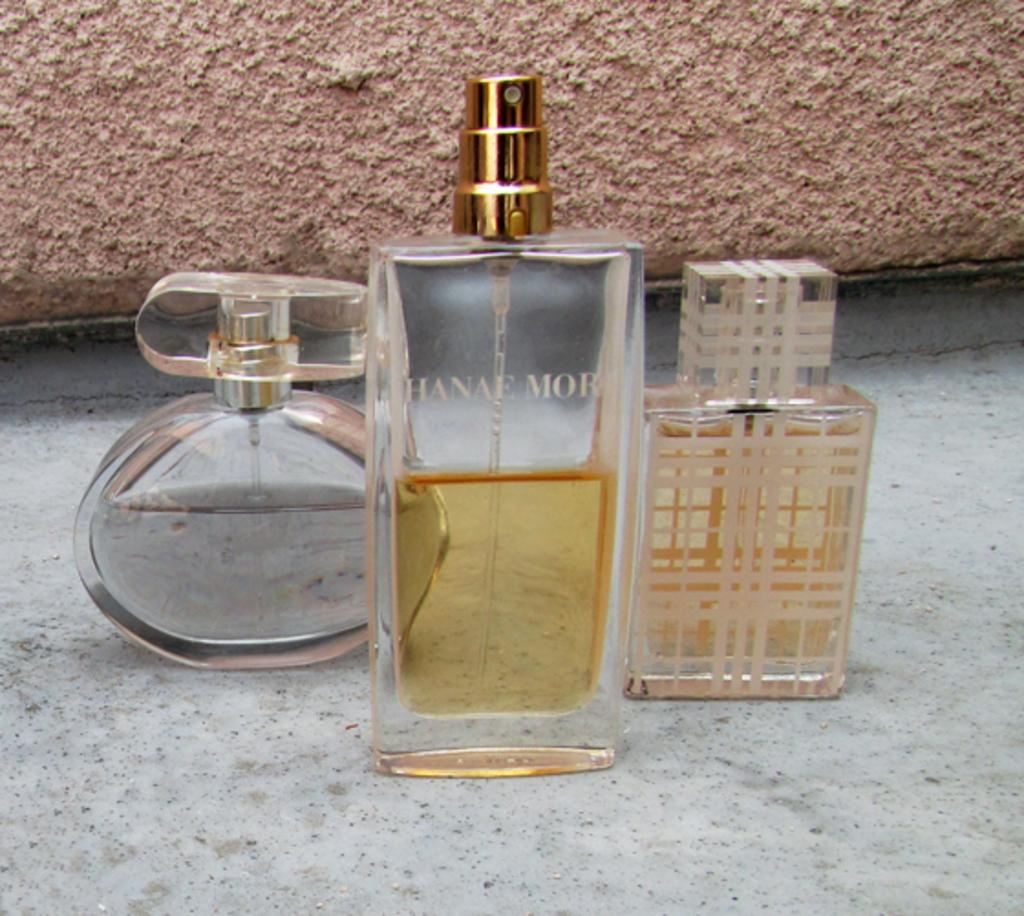<image>
Create a compact narrative representing the image presented. three different shaped bottle of perfume, one is hanae mor against a stone background 